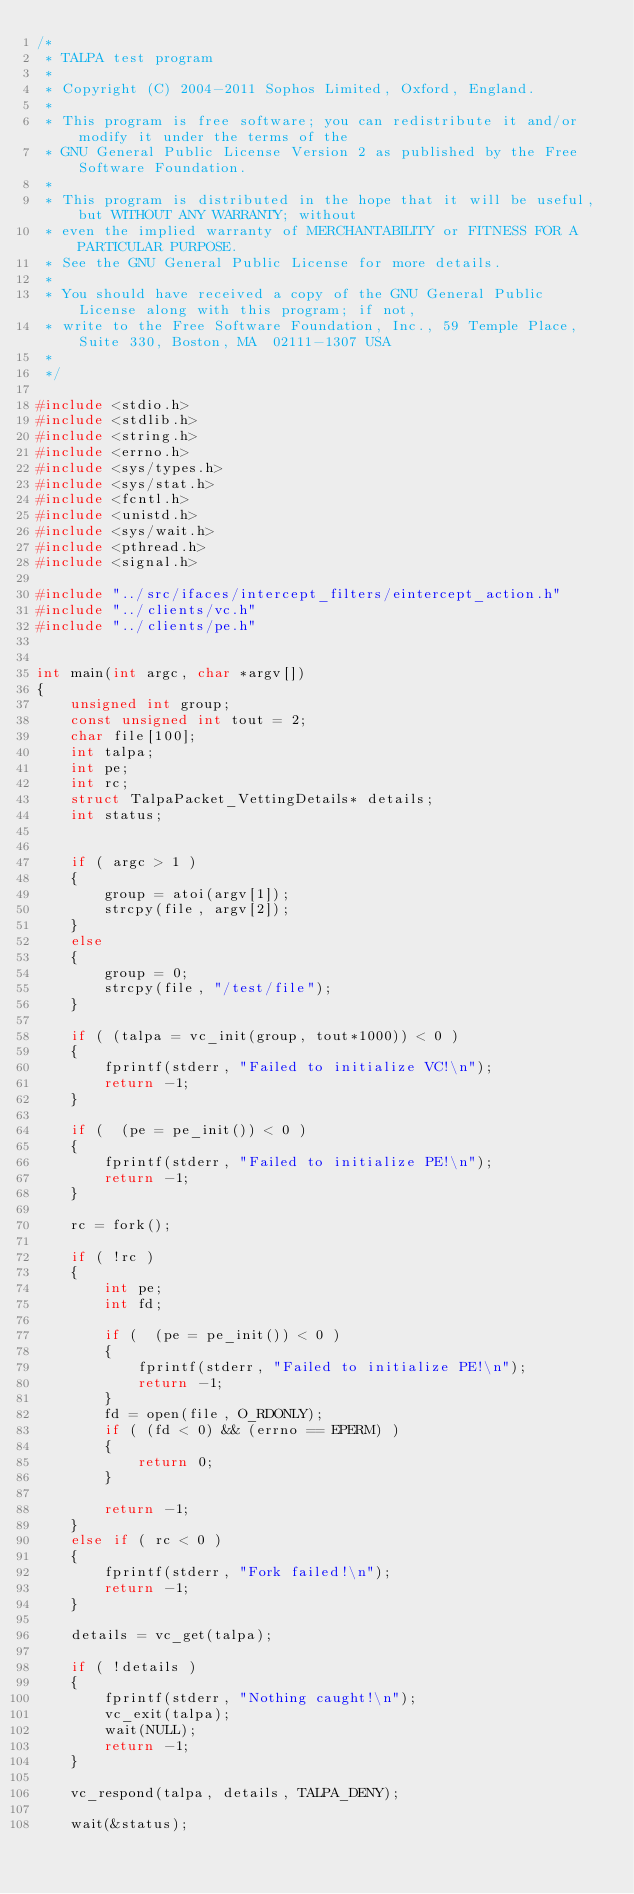Convert code to text. <code><loc_0><loc_0><loc_500><loc_500><_C_>/*
 * TALPA test program
 *
 * Copyright (C) 2004-2011 Sophos Limited, Oxford, England.
 *
 * This program is free software; you can redistribute it and/or modify it under the terms of the
 * GNU General Public License Version 2 as published by the Free Software Foundation.
 *
 * This program is distributed in the hope that it will be useful, but WITHOUT ANY WARRANTY; without
 * even the implied warranty of MERCHANTABILITY or FITNESS FOR A PARTICULAR PURPOSE.
 * See the GNU General Public License for more details.
 *
 * You should have received a copy of the GNU General Public License along with this program; if not,
 * write to the Free Software Foundation, Inc., 59 Temple Place, Suite 330, Boston, MA  02111-1307 USA
 *
 */

#include <stdio.h>
#include <stdlib.h>
#include <string.h>
#include <errno.h>
#include <sys/types.h>
#include <sys/stat.h>
#include <fcntl.h>
#include <unistd.h>
#include <sys/wait.h>
#include <pthread.h>
#include <signal.h>

#include "../src/ifaces/intercept_filters/eintercept_action.h"
#include "../clients/vc.h"
#include "../clients/pe.h"


int main(int argc, char *argv[])
{
    unsigned int group;
    const unsigned int tout = 2;
    char file[100];
    int talpa;
    int pe;
    int rc;
    struct TalpaPacket_VettingDetails* details;
    int status;


    if ( argc > 1 )
    {
        group = atoi(argv[1]);
        strcpy(file, argv[2]);
    }
    else
    {
        group = 0;
        strcpy(file, "/test/file");
    }

    if ( (talpa = vc_init(group, tout*1000)) < 0 )
    {
        fprintf(stderr, "Failed to initialize VC!\n");
        return -1;
    }

    if (  (pe = pe_init()) < 0 )
    {
        fprintf(stderr, "Failed to initialize PE!\n");
        return -1;
    }

    rc = fork();

    if ( !rc )
    {
        int pe;
        int fd;

        if (  (pe = pe_init()) < 0 )
        {
            fprintf(stderr, "Failed to initialize PE!\n");
            return -1;
        }
        fd = open(file, O_RDONLY);
        if ( (fd < 0) && (errno == EPERM) )
        {
            return 0;
        }

        return -1;
    }
    else if ( rc < 0 )
    {
        fprintf(stderr, "Fork failed!\n");
        return -1;
    }

    details = vc_get(talpa);

    if ( !details )
    {
        fprintf(stderr, "Nothing caught!\n");
        vc_exit(talpa);
        wait(NULL);
        return -1;
    }

    vc_respond(talpa, details, TALPA_DENY);

    wait(&status);
</code> 